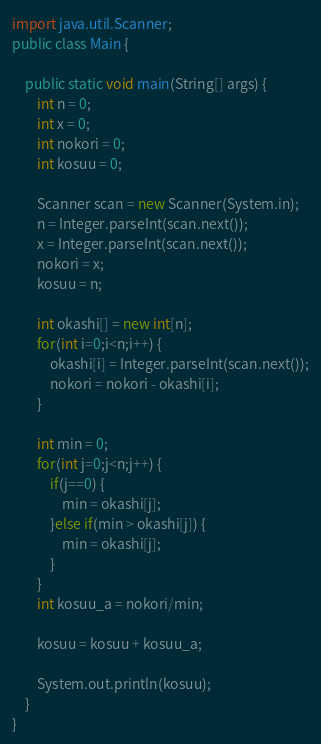<code> <loc_0><loc_0><loc_500><loc_500><_Java_>import java.util.Scanner;
public class Main {

	public static void main(String[] args) {
		int n = 0;
		int x = 0;
		int nokori = 0;
		int kosuu = 0;

		Scanner scan = new Scanner(System.in);
		n = Integer.parseInt(scan.next());
		x = Integer.parseInt(scan.next());
		nokori = x;
		kosuu = n;

		int okashi[] = new int[n];
		for(int i=0;i<n;i++) {
			okashi[i] = Integer.parseInt(scan.next());
			nokori = nokori - okashi[i];
		}

		int min = 0;
		for(int j=0;j<n;j++) {
			if(j==0) {
				min = okashi[j];
			}else if(min > okashi[j]) {
				min = okashi[j];
			}
		}
		int kosuu_a = nokori/min;

		kosuu = kosuu + kosuu_a;

		System.out.println(kosuu);
	}
}
</code> 